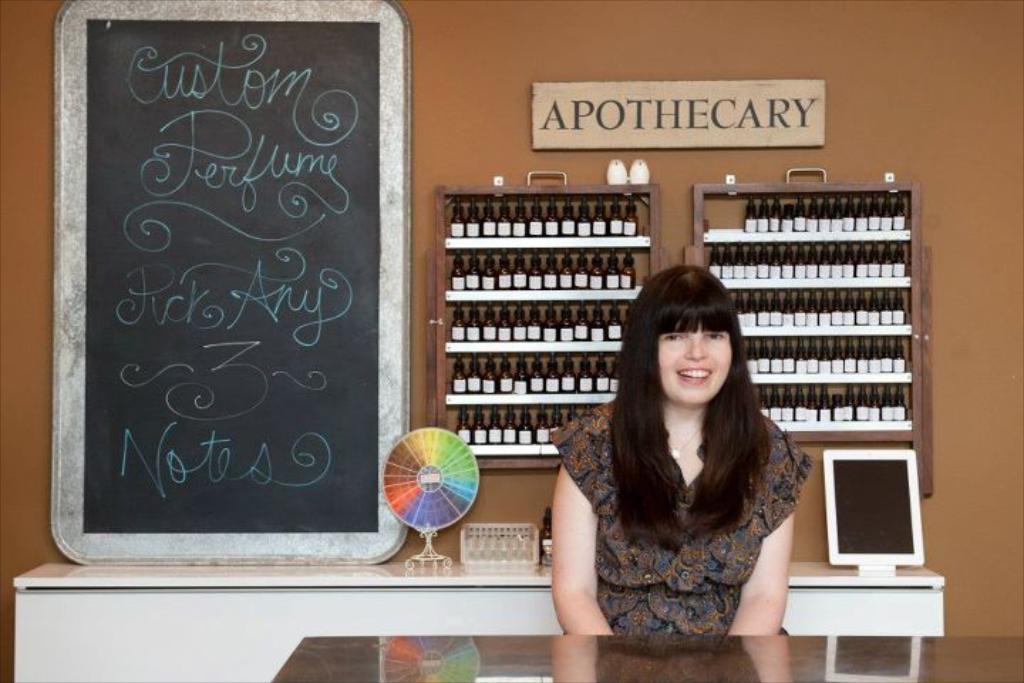Describe this image in one or two sentences. In this image, there is a person wearing clothes and sitting in front of this table. There is an another table behind this person contains blackboard, tablet and bottle. There are some bottles on the cupboard behind this person. There is a wall behind this person. 